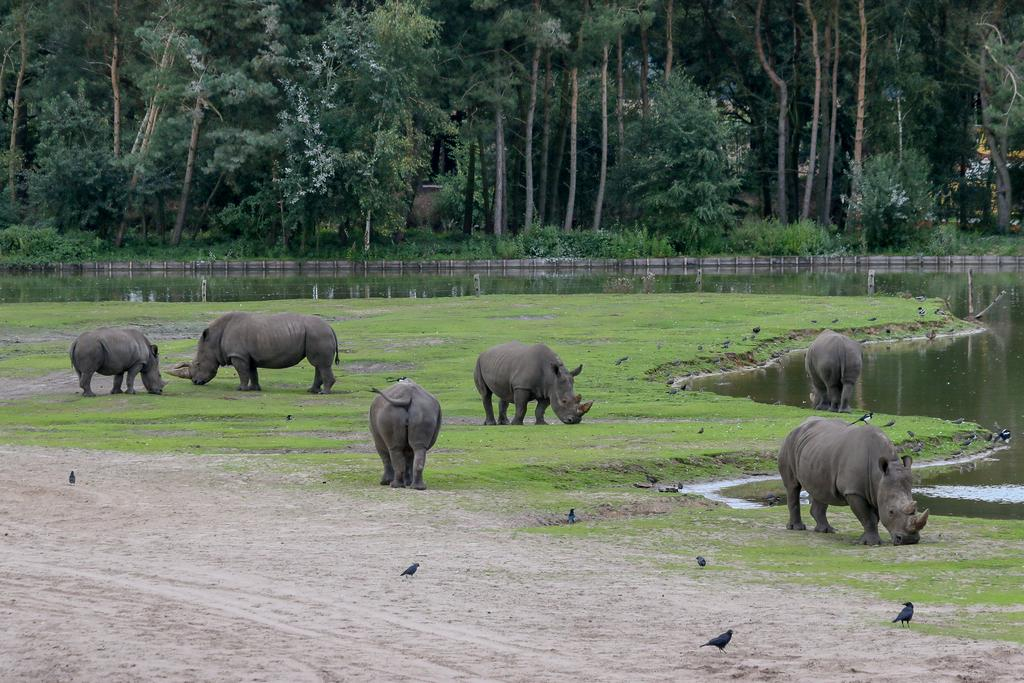What type of animals can be seen in the image? There are birds in the image. What is the large animal on the ground in the image? There is a black rhinoceros on the ground in the image. What type of vegetation is present on the ground in the image? There is grass on the ground in the image. What can be seen in the background of the image? There is water, trees, plants, and grass visible in the background of the image. What type of skin condition can be seen on the birds in the image? There is no indication of any skin condition on the birds in the image. What type of drum is being played by the black rhinoceros in the image? There is no drum present in the image; the black rhinoceros is on the ground. 